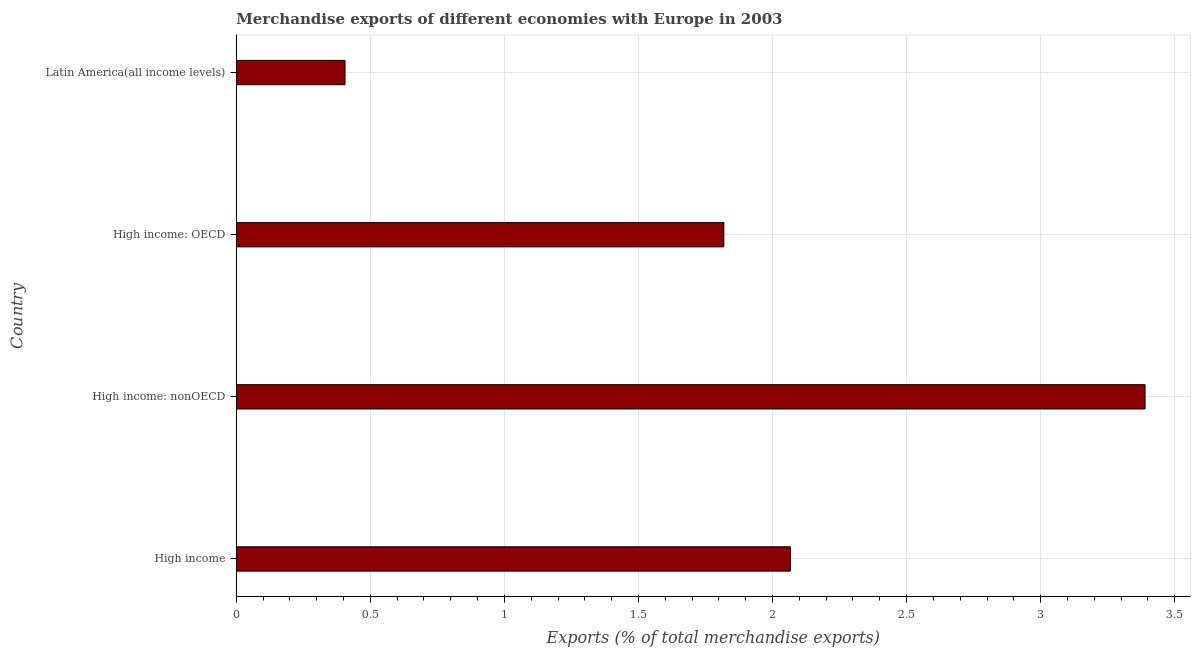Does the graph contain grids?
Your answer should be very brief. Yes. What is the title of the graph?
Offer a terse response. Merchandise exports of different economies with Europe in 2003. What is the label or title of the X-axis?
Provide a short and direct response. Exports (% of total merchandise exports). What is the merchandise exports in High income: nonOECD?
Your response must be concise. 3.39. Across all countries, what is the maximum merchandise exports?
Provide a short and direct response. 3.39. Across all countries, what is the minimum merchandise exports?
Give a very brief answer. 0.41. In which country was the merchandise exports maximum?
Give a very brief answer. High income: nonOECD. In which country was the merchandise exports minimum?
Offer a terse response. Latin America(all income levels). What is the sum of the merchandise exports?
Provide a short and direct response. 7.68. What is the difference between the merchandise exports in High income: OECD and High income: nonOECD?
Offer a terse response. -1.57. What is the average merchandise exports per country?
Provide a succinct answer. 1.92. What is the median merchandise exports?
Ensure brevity in your answer.  1.94. What is the ratio of the merchandise exports in High income: OECD to that in Latin America(all income levels)?
Provide a succinct answer. 4.48. Is the merchandise exports in High income less than that in Latin America(all income levels)?
Your response must be concise. No. Is the difference between the merchandise exports in High income: OECD and High income: nonOECD greater than the difference between any two countries?
Offer a terse response. No. What is the difference between the highest and the second highest merchandise exports?
Provide a succinct answer. 1.32. What is the difference between the highest and the lowest merchandise exports?
Your answer should be very brief. 2.98. In how many countries, is the merchandise exports greater than the average merchandise exports taken over all countries?
Offer a very short reply. 2. How many bars are there?
Your answer should be compact. 4. How many countries are there in the graph?
Keep it short and to the point. 4. Are the values on the major ticks of X-axis written in scientific E-notation?
Offer a very short reply. No. What is the Exports (% of total merchandise exports) of High income?
Keep it short and to the point. 2.07. What is the Exports (% of total merchandise exports) of High income: nonOECD?
Your answer should be compact. 3.39. What is the Exports (% of total merchandise exports) of High income: OECD?
Offer a terse response. 1.82. What is the Exports (% of total merchandise exports) in Latin America(all income levels)?
Provide a short and direct response. 0.41. What is the difference between the Exports (% of total merchandise exports) in High income and High income: nonOECD?
Your answer should be very brief. -1.32. What is the difference between the Exports (% of total merchandise exports) in High income and High income: OECD?
Make the answer very short. 0.25. What is the difference between the Exports (% of total merchandise exports) in High income and Latin America(all income levels)?
Offer a very short reply. 1.66. What is the difference between the Exports (% of total merchandise exports) in High income: nonOECD and High income: OECD?
Your answer should be compact. 1.57. What is the difference between the Exports (% of total merchandise exports) in High income: nonOECD and Latin America(all income levels)?
Provide a short and direct response. 2.98. What is the difference between the Exports (% of total merchandise exports) in High income: OECD and Latin America(all income levels)?
Make the answer very short. 1.41. What is the ratio of the Exports (% of total merchandise exports) in High income to that in High income: nonOECD?
Your answer should be compact. 0.61. What is the ratio of the Exports (% of total merchandise exports) in High income to that in High income: OECD?
Provide a short and direct response. 1.14. What is the ratio of the Exports (% of total merchandise exports) in High income to that in Latin America(all income levels)?
Your response must be concise. 5.09. What is the ratio of the Exports (% of total merchandise exports) in High income: nonOECD to that in High income: OECD?
Ensure brevity in your answer.  1.86. What is the ratio of the Exports (% of total merchandise exports) in High income: nonOECD to that in Latin America(all income levels)?
Your response must be concise. 8.36. What is the ratio of the Exports (% of total merchandise exports) in High income: OECD to that in Latin America(all income levels)?
Your response must be concise. 4.48. 